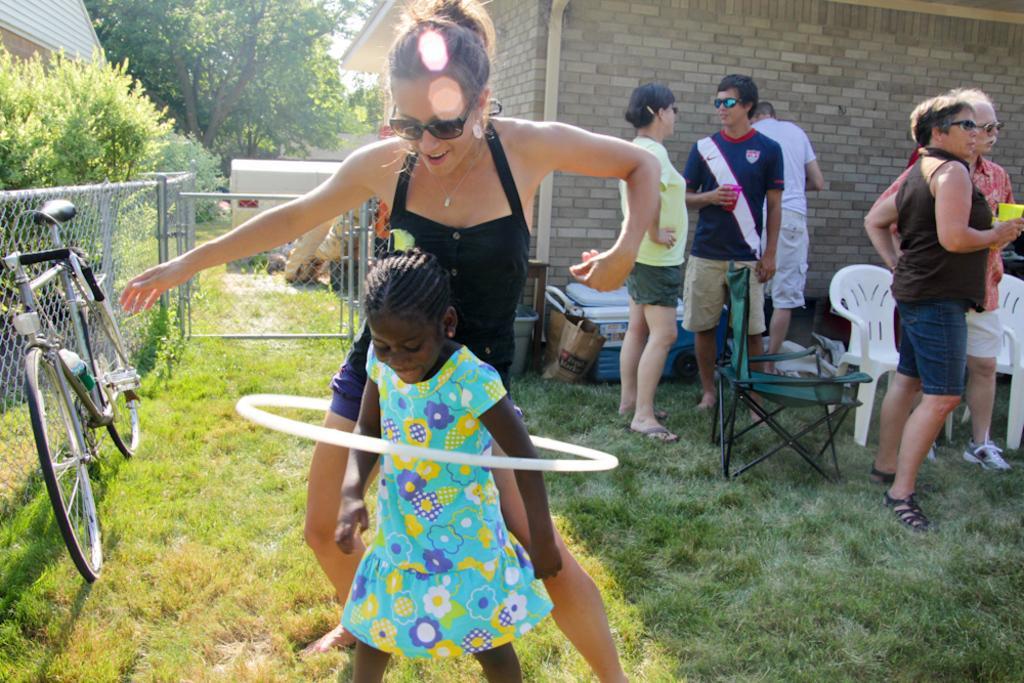Can you describe this image briefly? In this image I can see people among them some of them are holding glasses in hands. Here I can see chairs, a bicycle, fence, the grass and houses. In the background I can see trees, the sky and other objects on the ground. 